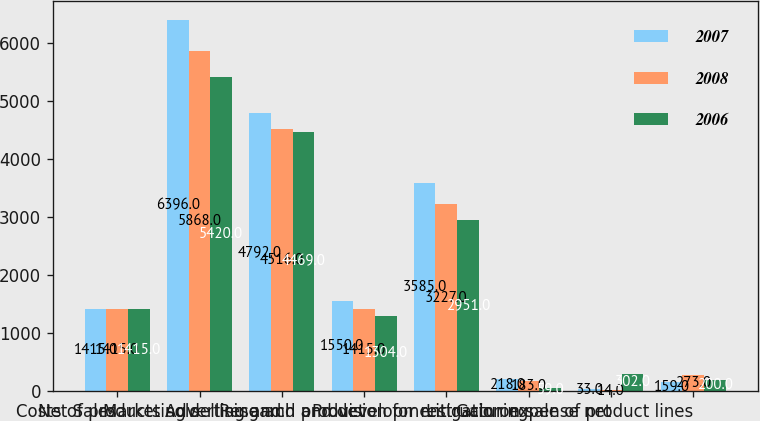Convert chart. <chart><loc_0><loc_0><loc_500><loc_500><stacked_bar_chart><ecel><fcel>Net Sales<fcel>Costs of products sold<fcel>Marketing selling and<fcel>Advertising and product<fcel>Research and development<fcel>Provision for restructuring<fcel>Litigation expense net<fcel>Gain on sale of product lines<nl><fcel>2007<fcel>1415<fcel>6396<fcel>4792<fcel>1550<fcel>3585<fcel>218<fcel>33<fcel>159<nl><fcel>2008<fcel>1415<fcel>5868<fcel>4516<fcel>1415<fcel>3227<fcel>183<fcel>14<fcel>273<nl><fcel>2006<fcel>1415<fcel>5420<fcel>4469<fcel>1304<fcel>2951<fcel>59<fcel>302<fcel>200<nl></chart> 